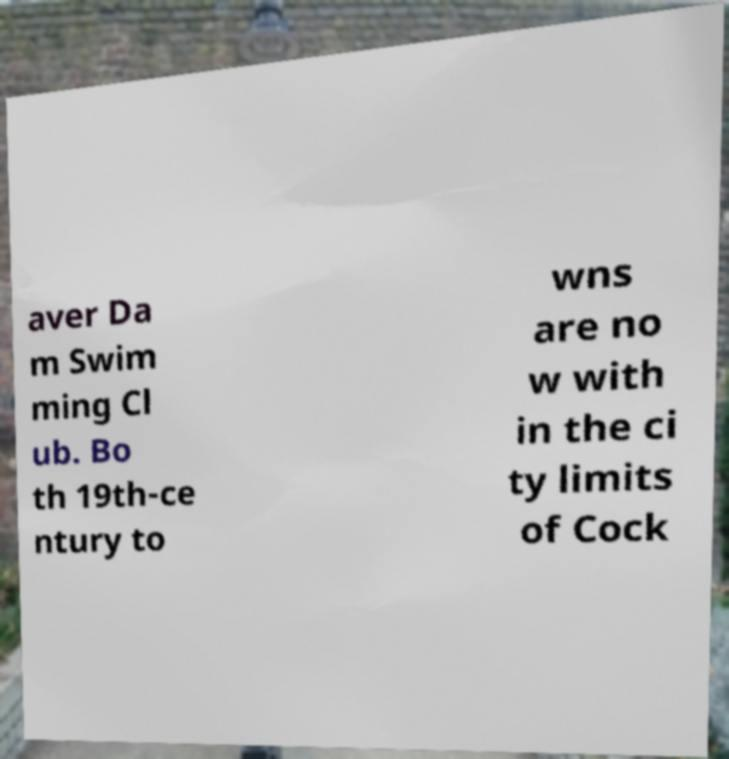Please read and relay the text visible in this image. What does it say? aver Da m Swim ming Cl ub. Bo th 19th-ce ntury to wns are no w with in the ci ty limits of Cock 